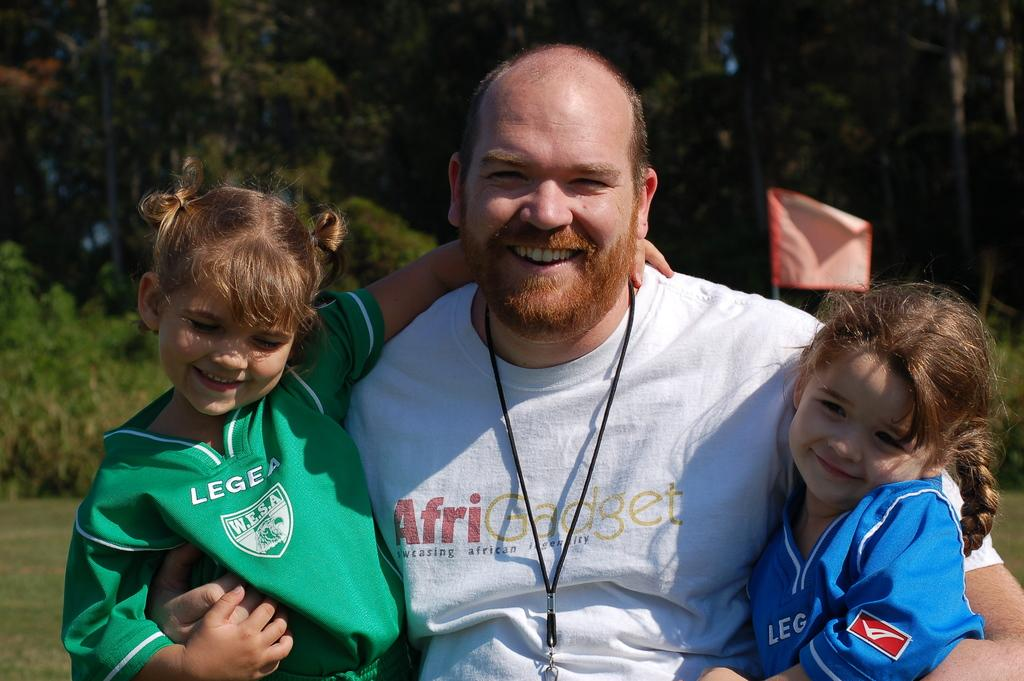<image>
Present a compact description of the photo's key features. a man is holding two kids and wearing a shirt with the word Afri on it 